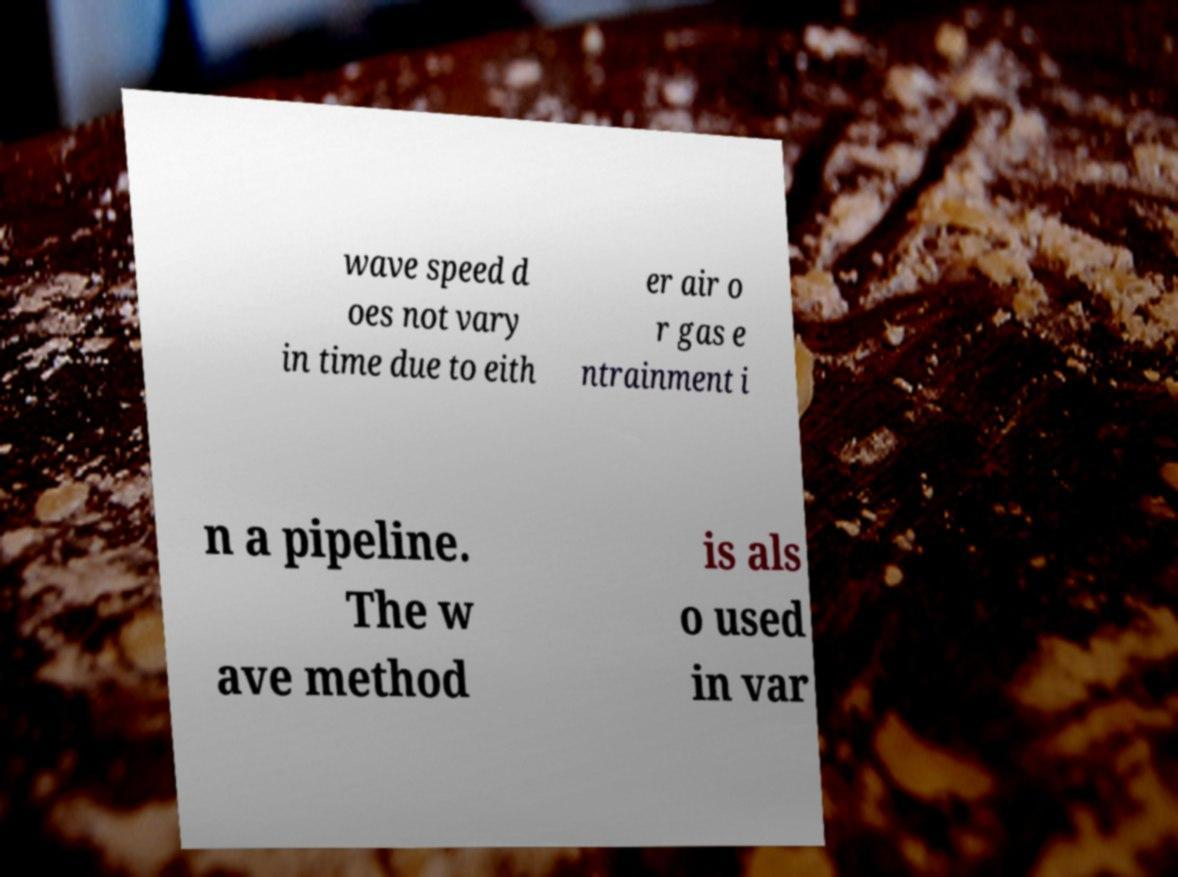What messages or text are displayed in this image? I need them in a readable, typed format. wave speed d oes not vary in time due to eith er air o r gas e ntrainment i n a pipeline. The w ave method is als o used in var 